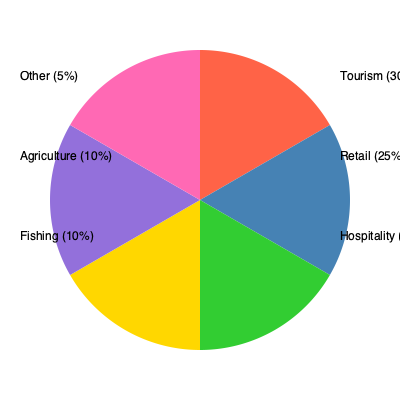Given the pie chart showing revenue sources for local businesses in Vieques, what percentage of the total revenue comes from industries that are directly impacted by ferry services (Tourism, Retail, and Hospitality combined)? To solve this problem, we need to follow these steps:

1. Identify the industries directly impacted by ferry services:
   - Tourism
   - Retail
   - Hospitality

2. Find the percentages for each of these industries:
   - Tourism: 30%
   - Retail: 25%
   - Hospitality: 20%

3. Add up the percentages:
   $30\% + 25\% + 20\% = 75\%$

Therefore, the total percentage of revenue that comes from industries directly impacted by ferry services is 75%.
Answer: 75% 